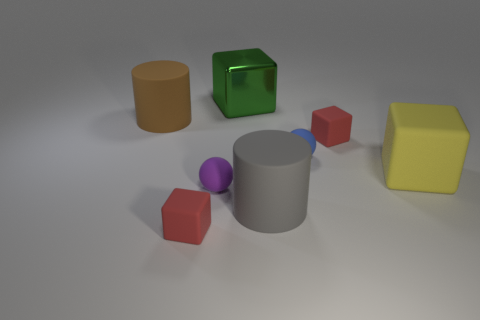There is a tiny red cube left of the big green shiny block; what is its material?
Your answer should be compact. Rubber. What number of large things are things or green metallic objects?
Offer a terse response. 4. There is a matte cylinder that is in front of the blue ball; does it have the same size as the large brown cylinder?
Make the answer very short. Yes. What material is the big yellow thing?
Ensure brevity in your answer.  Rubber. What is the material of the big object that is both to the right of the big brown object and left of the gray matte cylinder?
Provide a short and direct response. Metal. What number of things are rubber objects in front of the blue matte sphere or green objects?
Offer a terse response. 5. Is the color of the shiny cube the same as the large matte block?
Offer a very short reply. No. Is there a brown thing that has the same size as the blue ball?
Your answer should be very brief. No. What number of matte cylinders are behind the yellow rubber block and in front of the big yellow object?
Offer a very short reply. 0. What number of tiny red things are left of the brown matte object?
Give a very brief answer. 0. 